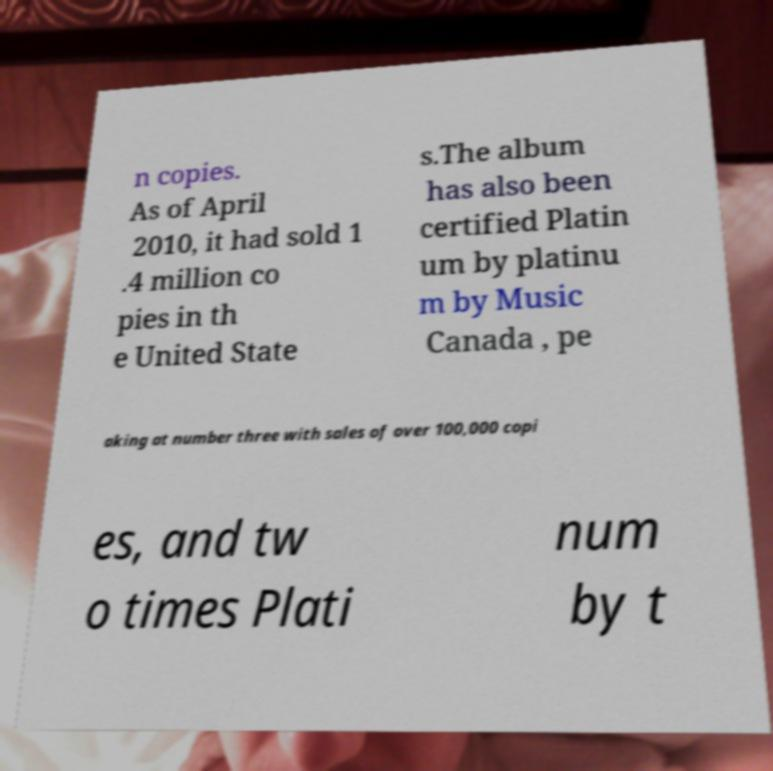Can you read and provide the text displayed in the image?This photo seems to have some interesting text. Can you extract and type it out for me? n copies. As of April 2010, it had sold 1 .4 million co pies in th e United State s.The album has also been certified Platin um by platinu m by Music Canada , pe aking at number three with sales of over 100,000 copi es, and tw o times Plati num by t 